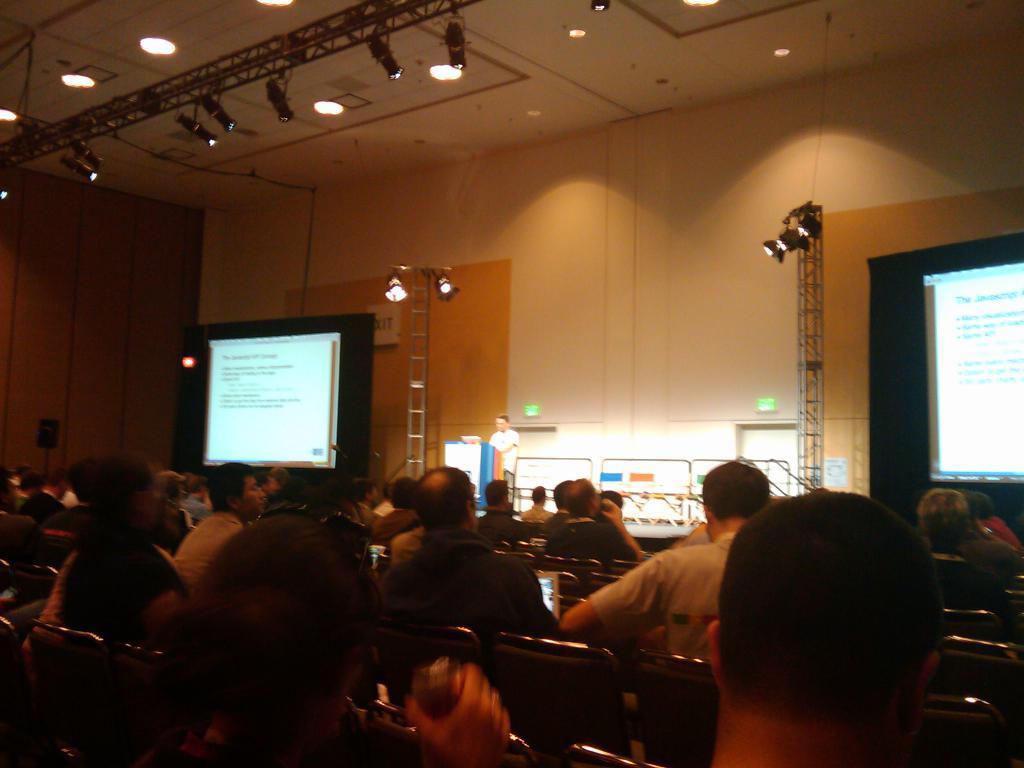Describe this image in one or two sentences. In this image there are group of persons sitting. In the background there is a man standing and in front of the man there is a podium. On the left side there is a screen and there is a stand and there lights on the top. On the right side there is a screen and there is a stand and on the stand there are lights. 